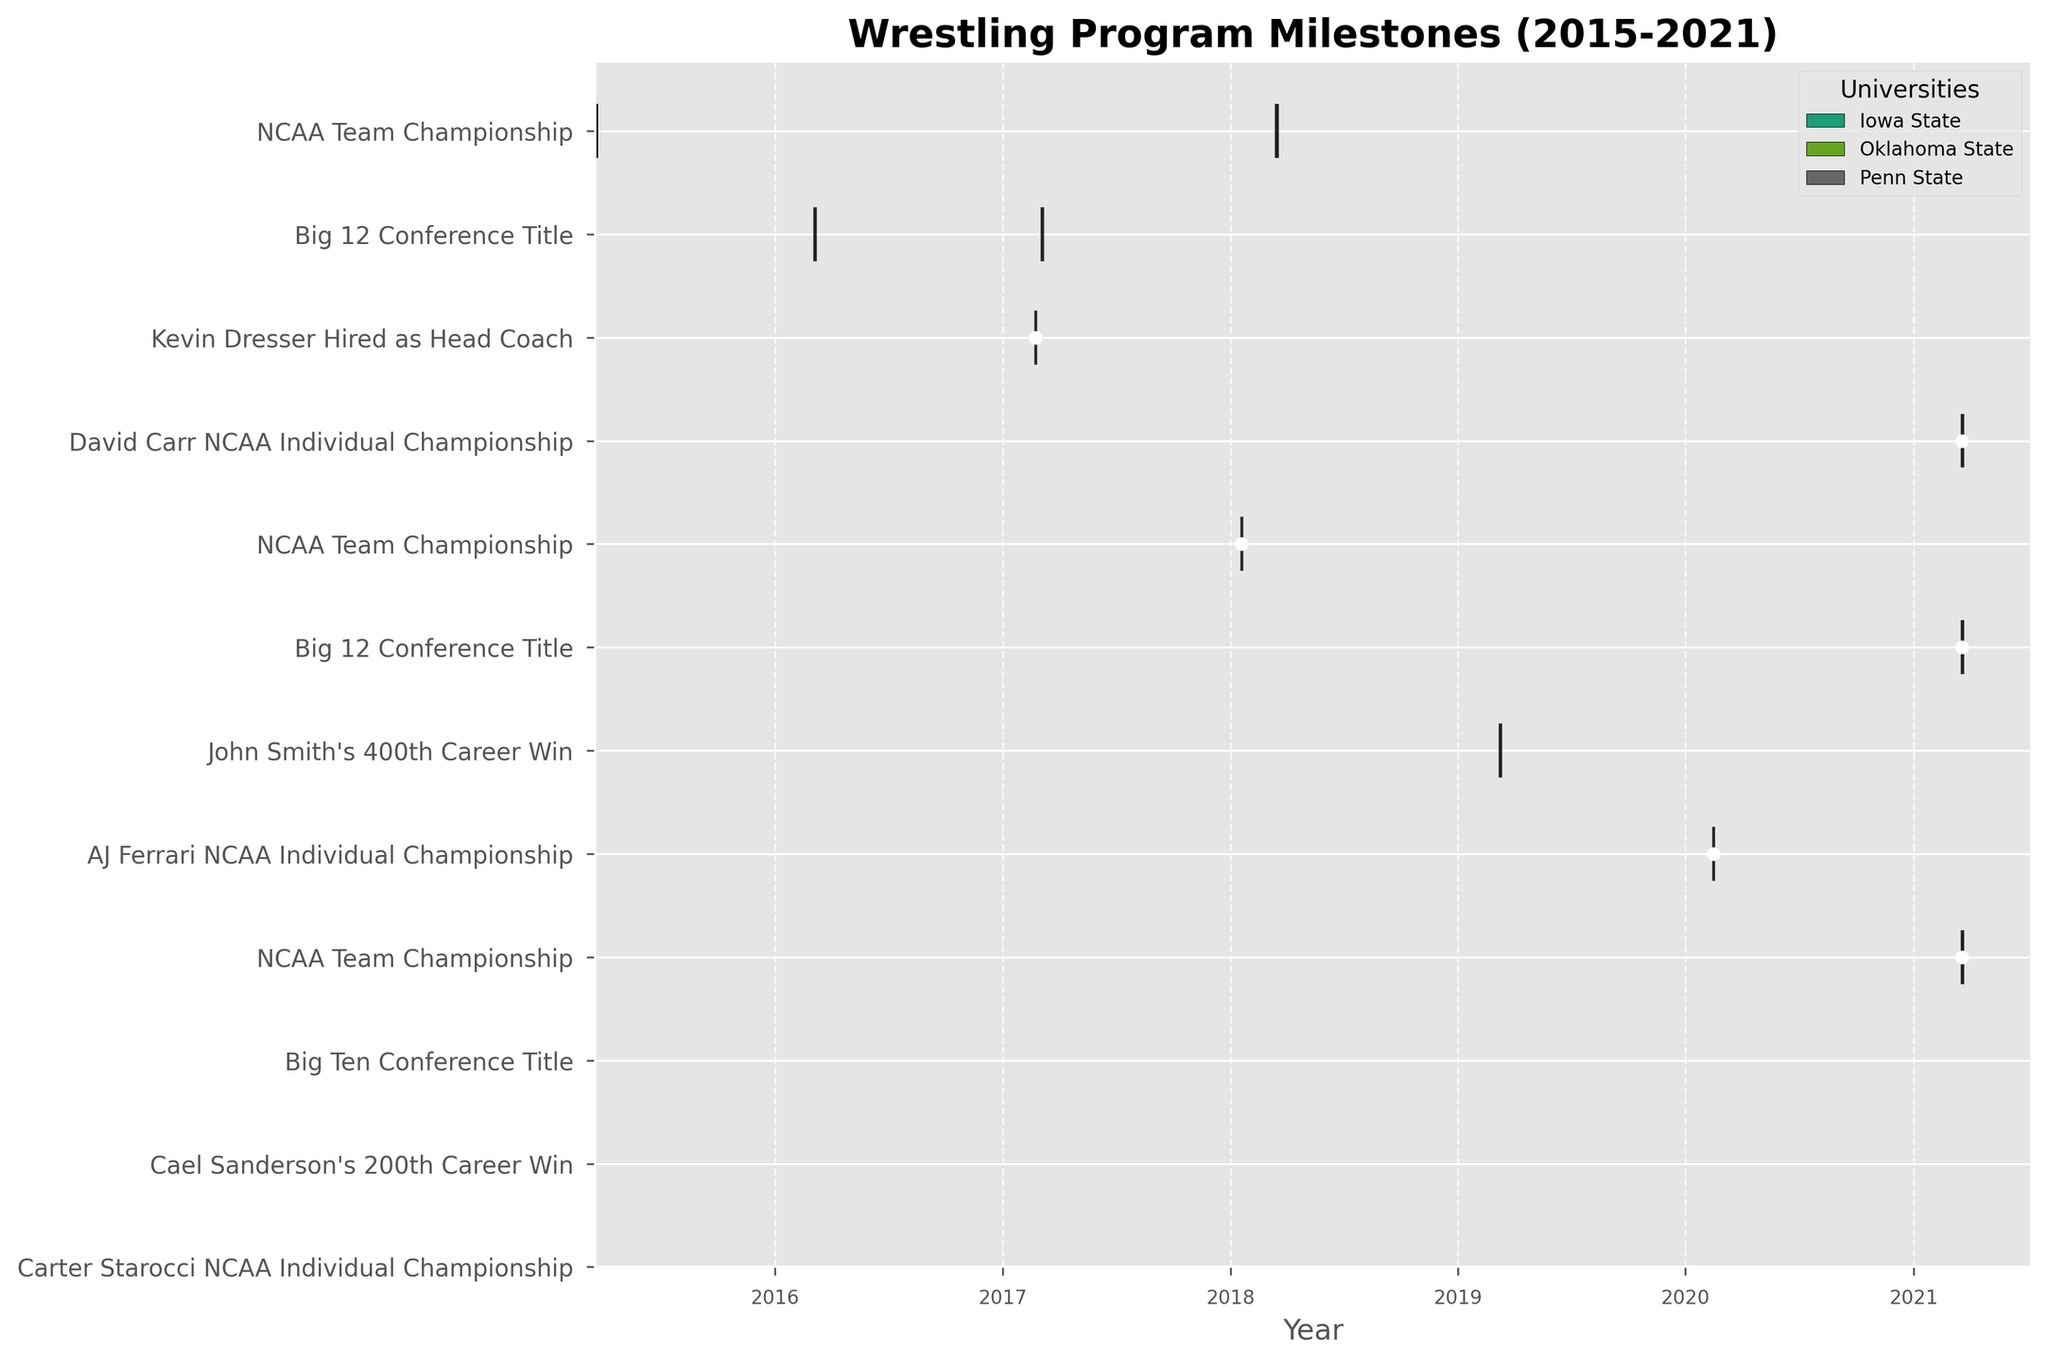What's the title of the figure? The title of the figure is located at the top center of the plot and is an important element that provides a summary of what the figure is about.
Answer: Wrestling Program Milestones (2015-2021) How many milestones are marked for Iowa State between 2015 and 2021? To find the number of milestones for Iowa State, count the number of bars (and points for one-day events) associated with the university. They usually share a common color.
Answer: 4 Which university reached a major milestone on March 20, 2021? Look for the markers on the specific date, March 20, 2021, and identify which universities have milestones on that date.
Answer: Iowa State, Oklahoma State, and Penn State What is the earliest milestone recorded in the figure? Check the earliest date on the x-axis where a bar or point indicates a milestone.
Answer: March 19, 2015 Which university has the most milestones within the represented timeline? Count the total number of bars and points for each university. The university with the most bars or points has the most milestones.
Answer: Penn State What is the duration of the "Big 12 Conference Title" milestone for Oklahoma State in the figure? Measure the length of the bar representing the "Big 12 Conference Title" for Oklahoma State by checking the start and end dates.
Answer: 2 days How many individual championships are recorded in the figure and which universities achieved them? Look for the milestones labeled as individual championships and note down the corresponding universities.
Answer: 3 (Iowa State, Oklahoma State, Penn State) What was the milestone for John Smith from Oklahoma State, and when did it happen? Identify the milestone associated with John Smith and locate the date beside that milestone.
Answer: 400th Career Win on January 19, 2018 During which years did Iowa State achieve their "NCAA Team Championship"? Identify the bars associated with "NCAA Team Championship" for Iowa State and read off the years from the x-axis.
Answer: 2015 Who is ahead in terms of the "Big Conference Titles" milestone between Iowa State and Oklahoma State during the given timeline? Compare the number and dates of the "Big Conference Titles" milestones for both universities.
Answer: It's a tie, each has 1 